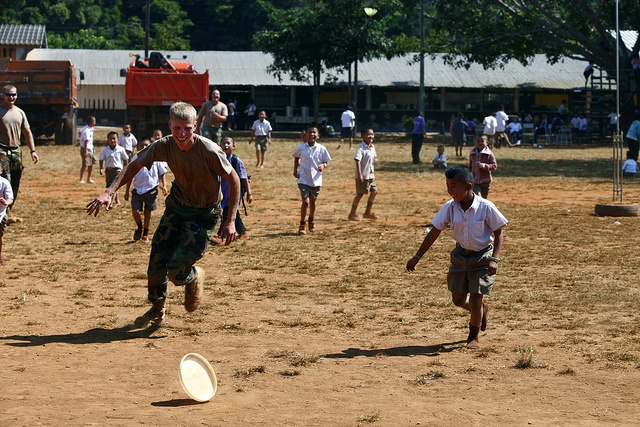Describe the objects in this image and their specific colors. I can see people in black, tan, and gray tones, people in black, maroon, and gray tones, people in black, gray, and maroon tones, truck in black, maroon, gray, and brown tones, and truck in black, maroon, brown, and gray tones in this image. 